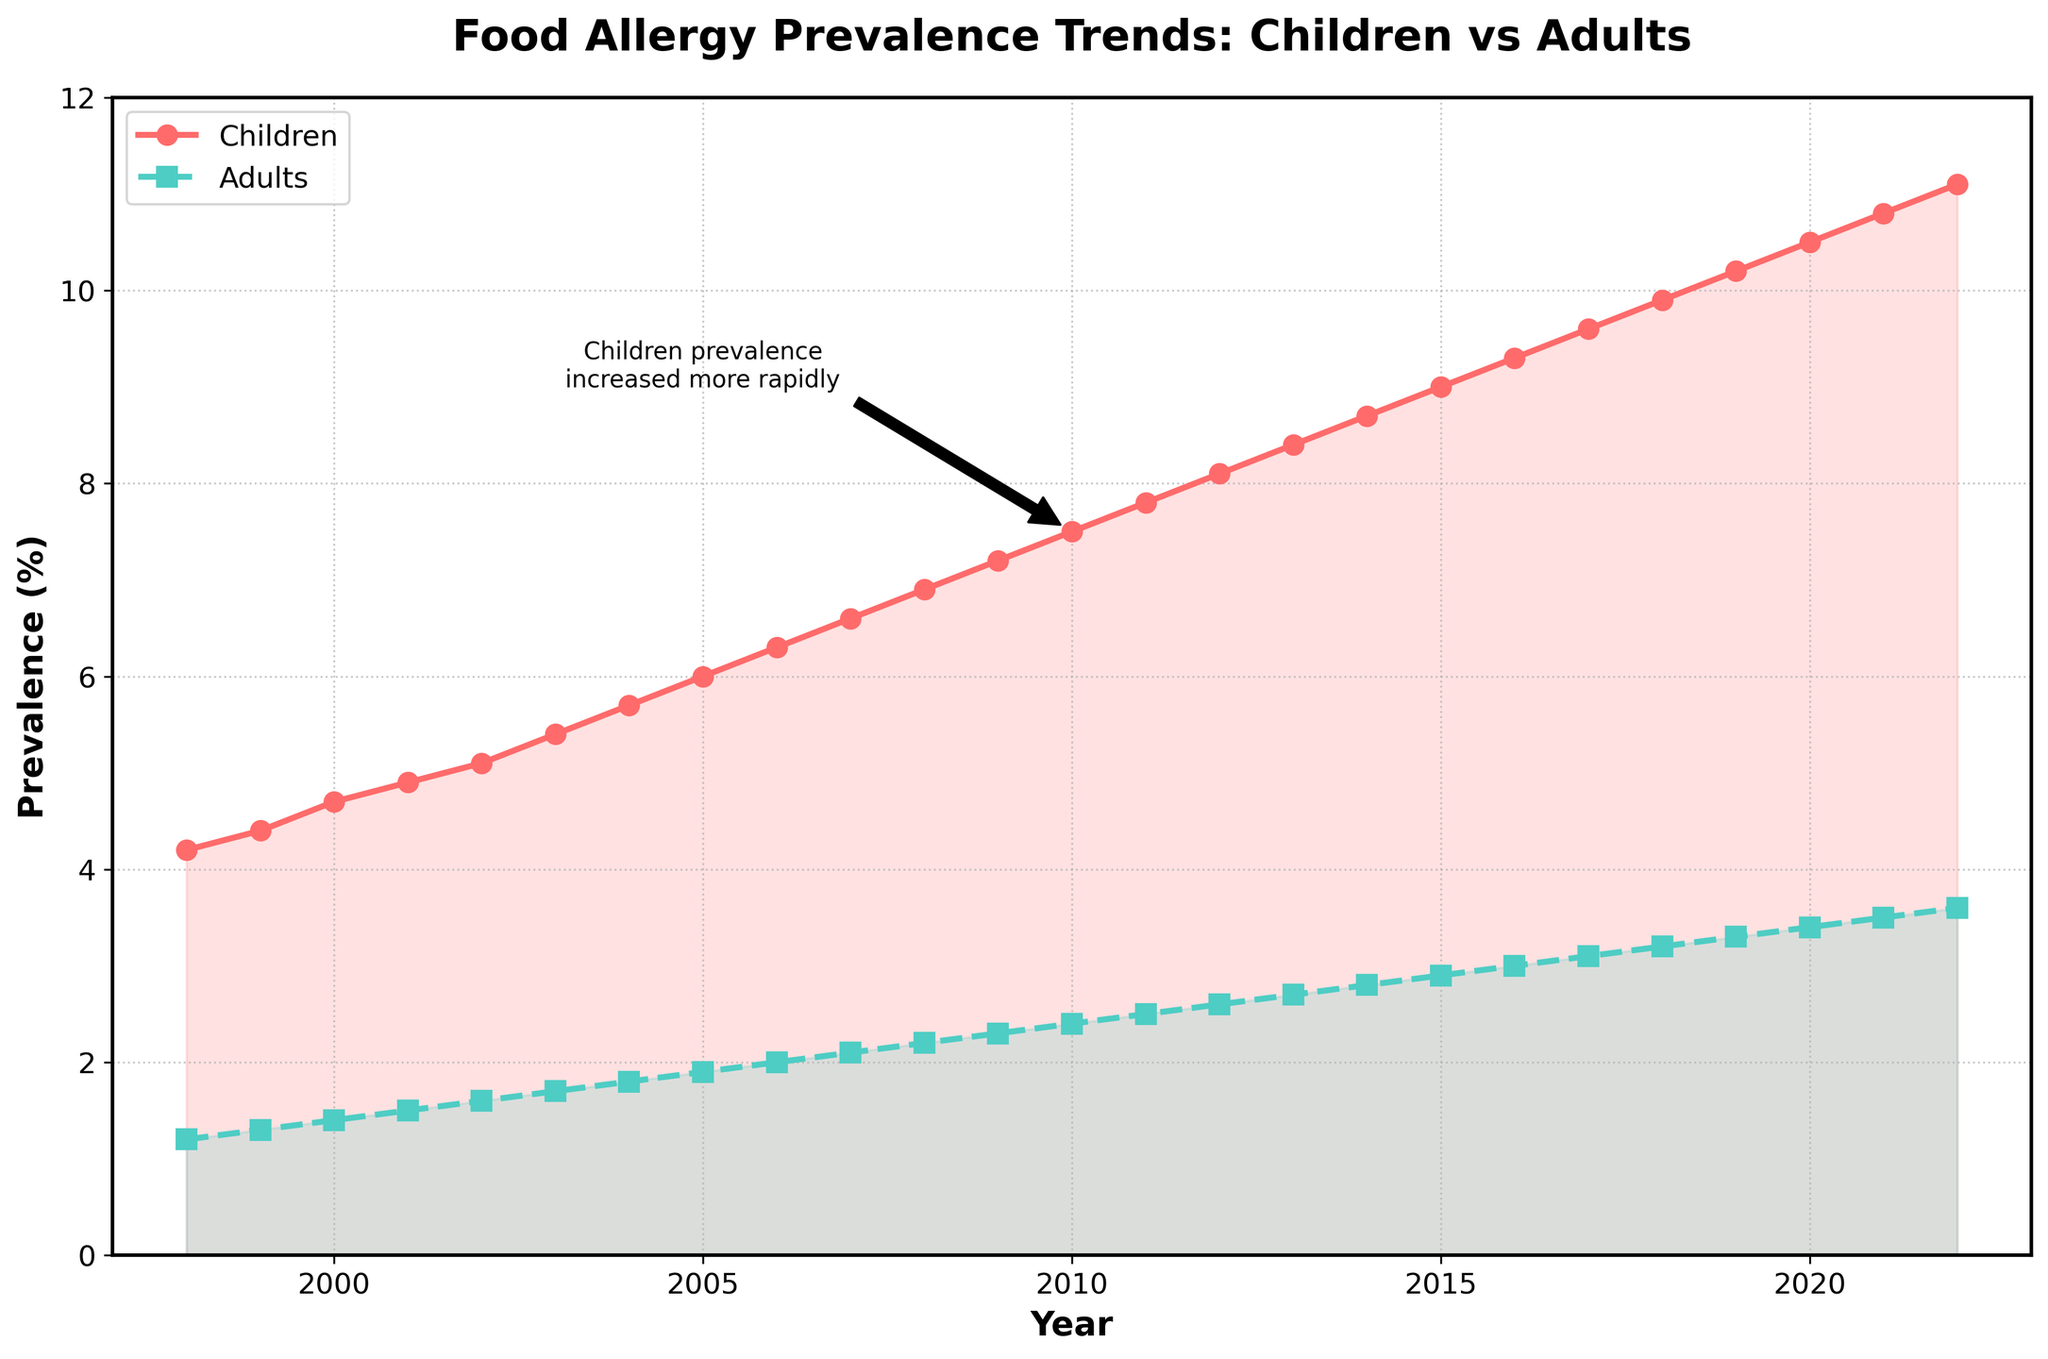What is the title of the figure? The title of the figure is displayed prominently at the top center. By directly reading it from the figure, we can see that it provides the subject of the plot.
Answer: Food Allergy Prevalence Trends: Children vs Adults What years are covered in the plot? By looking at the x-axis, which is labeled "Year," we can see the range of years from the numerical marks. The first and last tick marks are the starting and ending years.
Answer: 1998 to 2022 How does the prevalence of food allergies in children in 2022 compare to the prevalence in 1998? By examining the data points for children (represented by the line with circles) at the years 1998 and 2022, you can see the values on the y-axis for these points.
Answer: The prevalence in children increased from 4.2% in 1998 to 11.1% in 2022 What color represents adult food allergy prevalence in the plot? By observing the legend and the lines in the plot, we can see which color corresponds to "Adults." The line with squares and the legend entry for "Adults" use this color.
Answer: Teal What is the approximate difference in food allergy prevalence between children and adults in 2020? Locate the data points for both children and adults in the year 2020. Subtract the adult prevalence value from the child prevalence value.
Answer: 10.5% - 3.4% = 7.1% Over which period did the children’s food allergy prevalence show a noticeable rapid increase, as indicated by the annotation? The annotation and the line trend in the plot guide us to the period where the increase in children’s food allergy prevalence was most rapid. The annotation points to around 2010 and highlights a steeper slope following this year.
Answer: Around 2010 and the following years How do the trends in food allergy prevalence for children and adults compare over the entire 25-year period? By observing the slope and pattern of the two plotted lines, we can compare how the prevalence changes over time for both groups. The steeper line indicates a more significant increase.
Answer: The prevalence increased more rapidly in children compared to adults Which year shows the smallest gap between the prevalence in children and adults? Compare the gap (the vertical difference between data points) for each year and identify the smallest one. From the visual trend, it’s the earliest years where the gap seems closest.
Answer: 1998 What is the general trend in food allergy prevalence in adults over the years? By observing the line representing adult prevalence over the years, we can describe the overall direction or pattern it follows.
Answer: It shows a gradual increase What is the significance of the shaded area between the lines for children and adults? The shaded areas under each line help visually emphasize the space indicating prevalence values. This area differentiation aids in contrasting and comparing the magnitude of prevalence between children and adults.
Answer: Indicates the difference in prevalence levels between children and adults 